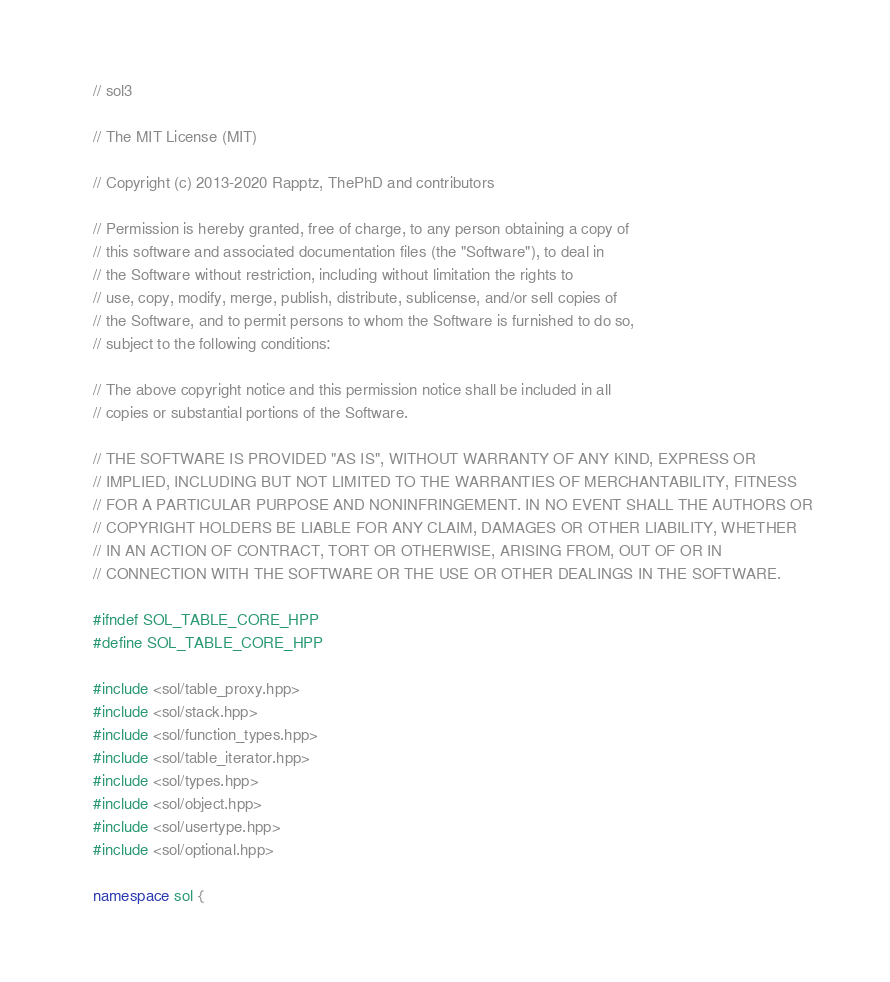Convert code to text. <code><loc_0><loc_0><loc_500><loc_500><_C++_>// sol3

// The MIT License (MIT)

// Copyright (c) 2013-2020 Rapptz, ThePhD and contributors

// Permission is hereby granted, free of charge, to any person obtaining a copy of
// this software and associated documentation files (the "Software"), to deal in
// the Software without restriction, including without limitation the rights to
// use, copy, modify, merge, publish, distribute, sublicense, and/or sell copies of
// the Software, and to permit persons to whom the Software is furnished to do so,
// subject to the following conditions:

// The above copyright notice and this permission notice shall be included in all
// copies or substantial portions of the Software.

// THE SOFTWARE IS PROVIDED "AS IS", WITHOUT WARRANTY OF ANY KIND, EXPRESS OR
// IMPLIED, INCLUDING BUT NOT LIMITED TO THE WARRANTIES OF MERCHANTABILITY, FITNESS
// FOR A PARTICULAR PURPOSE AND NONINFRINGEMENT. IN NO EVENT SHALL THE AUTHORS OR
// COPYRIGHT HOLDERS BE LIABLE FOR ANY CLAIM, DAMAGES OR OTHER LIABILITY, WHETHER
// IN AN ACTION OF CONTRACT, TORT OR OTHERWISE, ARISING FROM, OUT OF OR IN
// CONNECTION WITH THE SOFTWARE OR THE USE OR OTHER DEALINGS IN THE SOFTWARE.

#ifndef SOL_TABLE_CORE_HPP
#define SOL_TABLE_CORE_HPP

#include <sol/table_proxy.hpp>
#include <sol/stack.hpp>
#include <sol/function_types.hpp>
#include <sol/table_iterator.hpp>
#include <sol/types.hpp>
#include <sol/object.hpp>
#include <sol/usertype.hpp>
#include <sol/optional.hpp>

namespace sol {</code> 